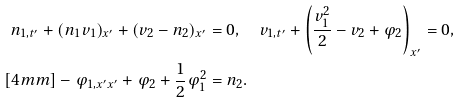<formula> <loc_0><loc_0><loc_500><loc_500>n _ { 1 , t ^ { \prime } } + ( n _ { 1 } v _ { 1 } ) _ { x ^ { \prime } } + ( v _ { 2 } - n _ { 2 } ) _ { x ^ { \prime } } & = 0 , \quad v _ { 1 , t ^ { \prime } } + \left ( \frac { v _ { 1 } ^ { 2 } } { 2 } - v _ { 2 } + \varphi _ { 2 } \right ) _ { x ^ { \prime } } = 0 , \\ [ 4 m m ] - \varphi _ { 1 , x ^ { \prime } x ^ { \prime } } + \varphi _ { 2 } + \frac { 1 } { 2 } \varphi _ { 1 } ^ { 2 } & = n _ { 2 } .</formula> 